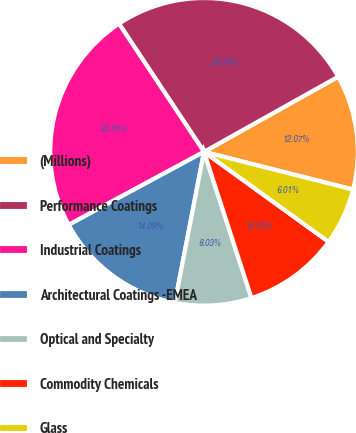<chart> <loc_0><loc_0><loc_500><loc_500><pie_chart><fcel>(Millions)<fcel>Performance Coatings<fcel>Industrial Coatings<fcel>Architectural Coatings -EMEA<fcel>Optical and Specialty<fcel>Commodity Chemicals<fcel>Glass<nl><fcel>12.07%<fcel>26.2%<fcel>23.55%<fcel>14.09%<fcel>8.03%<fcel>10.05%<fcel>6.01%<nl></chart> 